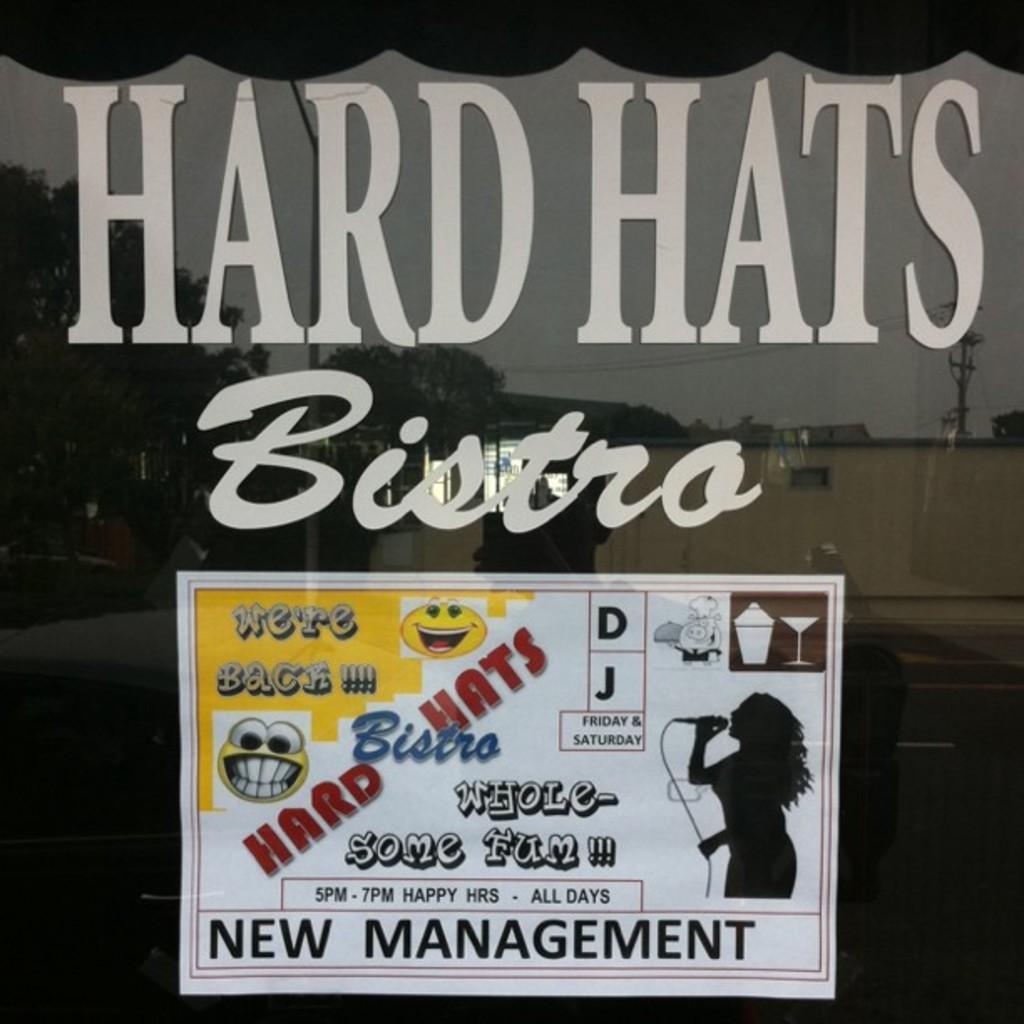In one or two sentences, can you explain what this image depicts? In this image there is a glass and we can see a poster pasted on the glass and there is text. 